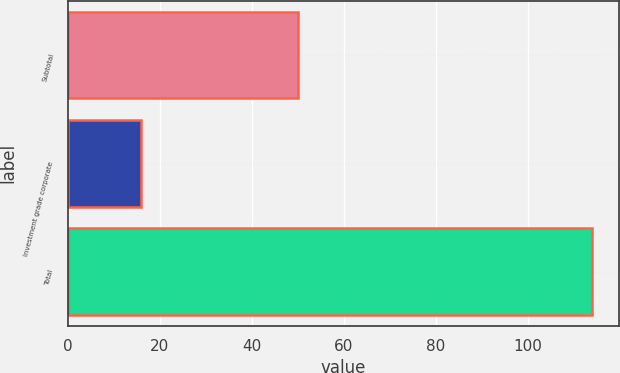Convert chart to OTSL. <chart><loc_0><loc_0><loc_500><loc_500><bar_chart><fcel>Subtotal<fcel>Investment grade corporate<fcel>Total<nl><fcel>50<fcel>16<fcel>114<nl></chart> 